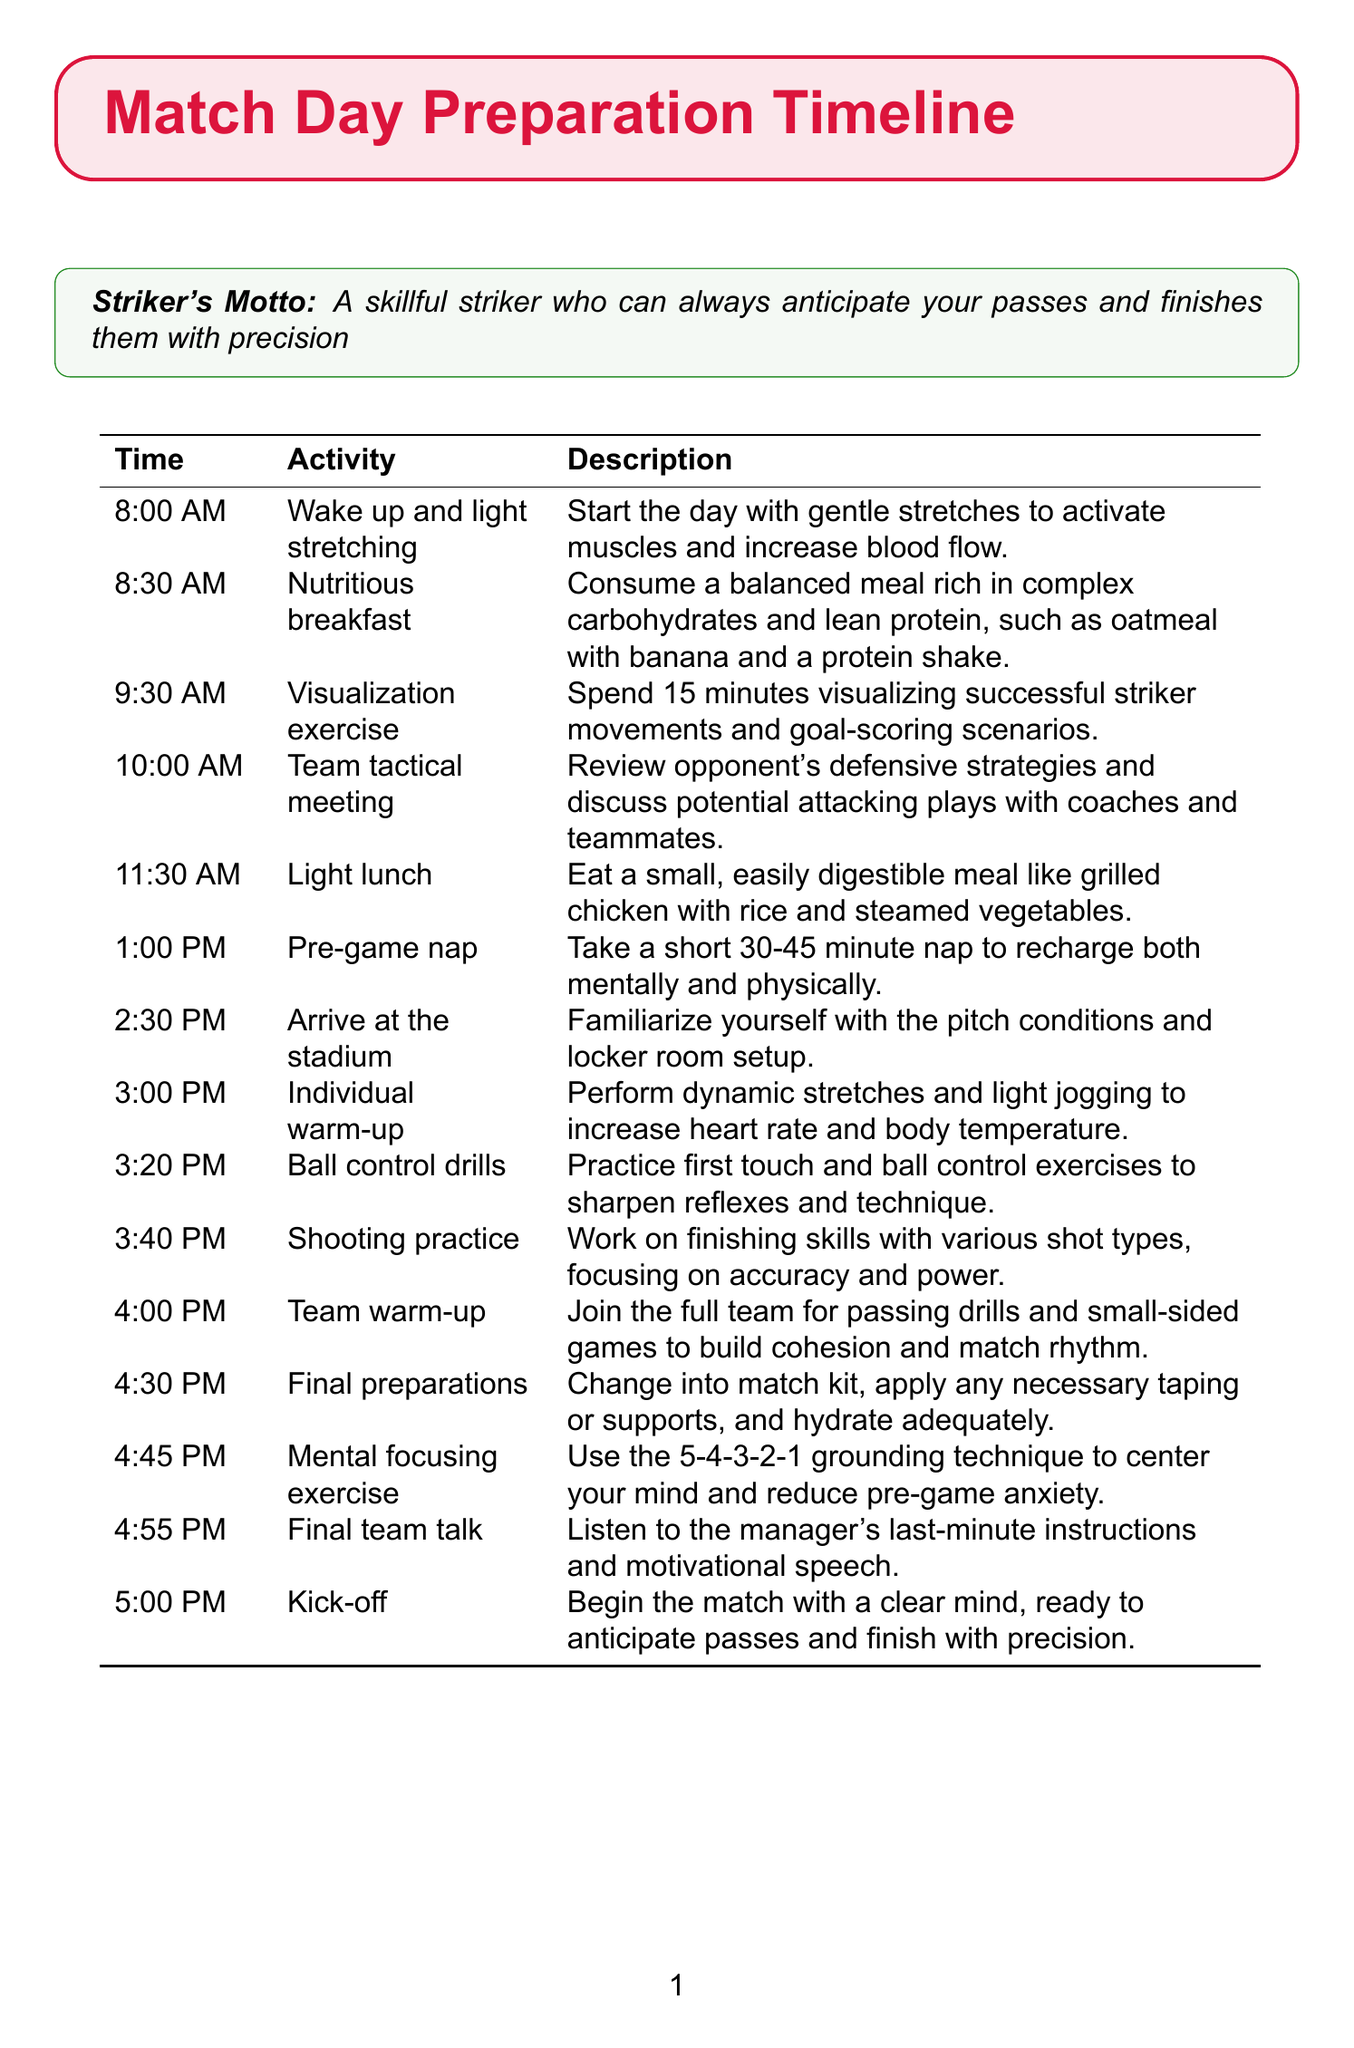what time is the first activity? The first activity listed in the schedule is "Wake up and light stretching" at 8:00 AM.
Answer: 8:00 AM what is the main purpose of the visualization exercise? The visualization exercise is to spend 15 minutes visualizing successful striker movements and goal-scoring scenarios before the match.
Answer: Visualizing successful striker movements how long is the pre-game nap? The schedule specifies taking a short nap that lasts between 30 to 45 minutes to recharge.
Answer: 30-45 minutes what activity takes place at 4:45 PM? The final activity before kick-off is the "Mental focusing exercise" which uses the 5-4-3-2-1 grounding technique to center the mind.
Answer: Mental focusing exercise how many warm-up activities are listed before kick-off? There are three distinct warm-up activities listed prior to kick-off, starting from "Individual warm-up" to "Team warm-up".
Answer: Three what is included in a nutritious breakfast? The document specifies a balanced meal rich in complex carbohydrates and lean protein such as oatmeal with a banana and a protein shake.
Answer: Oatmeal with banana and a protein shake what is the last activity before the match starts? The last organized activity mentioned before the match is the "Final team talk," where the manager gives instructions and motivation.
Answer: Final team talk at what time should the team arrive at the stadium? The schedule states that the team should arrive at the stadium by 2:30 PM to familiarize themselves with the surroundings.
Answer: 2:30 PM what is the duration of the light lunch? The light lunch is scheduled for 11:30 AM, but the duration is not explicitly stated, only that it's a small, easily digestible meal.
Answer: Not specified 